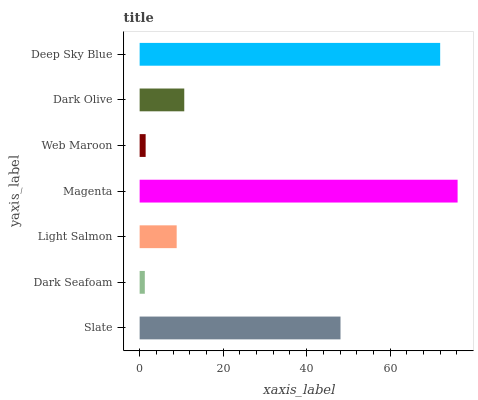Is Dark Seafoam the minimum?
Answer yes or no. Yes. Is Magenta the maximum?
Answer yes or no. Yes. Is Light Salmon the minimum?
Answer yes or no. No. Is Light Salmon the maximum?
Answer yes or no. No. Is Light Salmon greater than Dark Seafoam?
Answer yes or no. Yes. Is Dark Seafoam less than Light Salmon?
Answer yes or no. Yes. Is Dark Seafoam greater than Light Salmon?
Answer yes or no. No. Is Light Salmon less than Dark Seafoam?
Answer yes or no. No. Is Dark Olive the high median?
Answer yes or no. Yes. Is Dark Olive the low median?
Answer yes or no. Yes. Is Deep Sky Blue the high median?
Answer yes or no. No. Is Slate the low median?
Answer yes or no. No. 